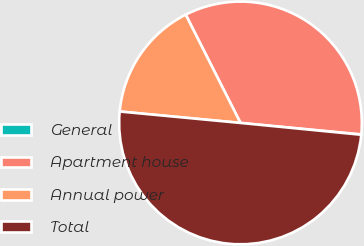<chart> <loc_0><loc_0><loc_500><loc_500><pie_chart><fcel>General<fcel>Apartment house<fcel>Annual power<fcel>Total<nl><fcel>0.05%<fcel>33.96%<fcel>16.04%<fcel>49.95%<nl></chart> 